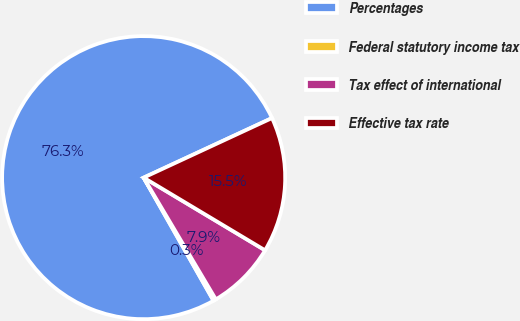Convert chart. <chart><loc_0><loc_0><loc_500><loc_500><pie_chart><fcel>Percentages<fcel>Federal statutory income tax<fcel>Tax effect of international<fcel>Effective tax rate<nl><fcel>76.31%<fcel>0.3%<fcel>7.9%<fcel>15.5%<nl></chart> 